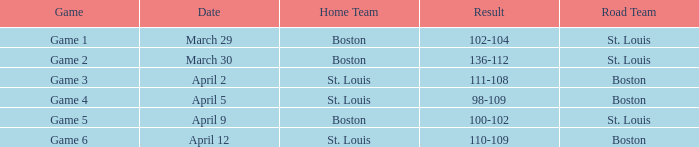On march 30, which game number is scheduled? Game 2. 